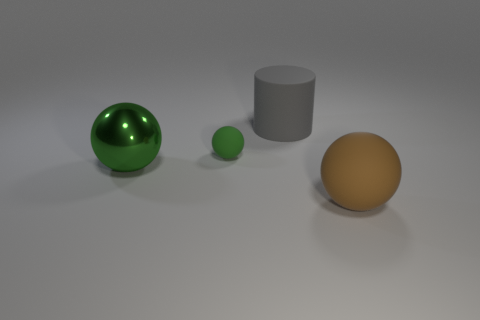What number of other objects are the same shape as the green metal object?
Ensure brevity in your answer.  2. There is a matte ball that is behind the thing on the right side of the big rubber object on the left side of the brown sphere; how big is it?
Provide a short and direct response. Small. Are there more brown objects that are in front of the big gray rubber cylinder than green objects?
Give a very brief answer. No. Is there a large green rubber block?
Ensure brevity in your answer.  No. What number of green matte balls are the same size as the rubber cylinder?
Ensure brevity in your answer.  0. Is the number of brown matte spheres behind the gray rubber cylinder greater than the number of big gray matte cylinders that are to the right of the brown rubber sphere?
Your answer should be very brief. No. There is a brown ball that is the same size as the cylinder; what material is it?
Your answer should be very brief. Rubber. What shape is the green rubber thing?
Ensure brevity in your answer.  Sphere. What number of green objects are either large matte cylinders or rubber things?
Provide a short and direct response. 1. There is a brown sphere that is made of the same material as the gray cylinder; what size is it?
Offer a terse response. Large. 